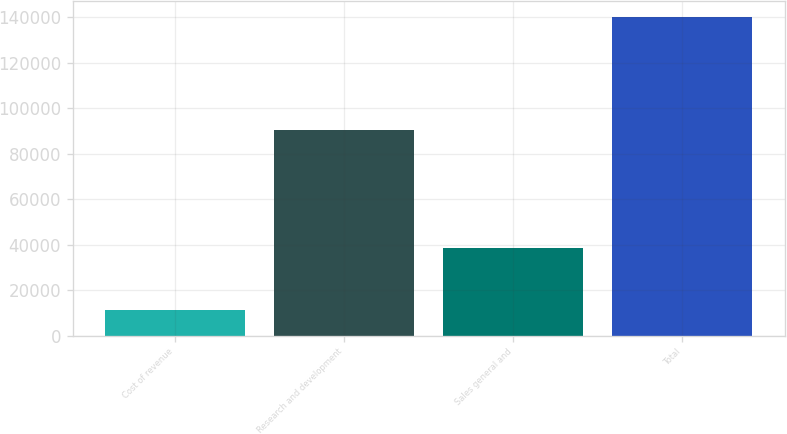Convert chart. <chart><loc_0><loc_0><loc_500><loc_500><bar_chart><fcel>Cost of revenue<fcel>Research and development<fcel>Sales general and<fcel>Total<nl><fcel>11412<fcel>90456<fcel>38373<fcel>140241<nl></chart> 